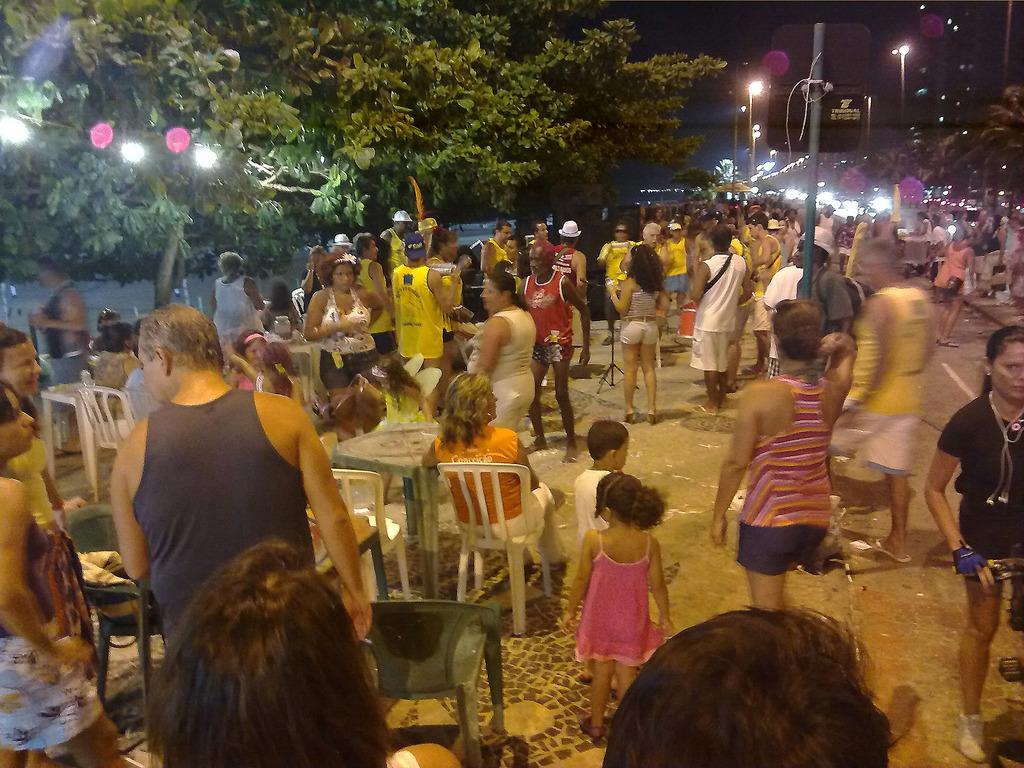In one or two sentences, can you explain what this image depicts? This image is taken during the night time. In this image we can see the light poles, lights, trees and also many people. We can see some people standing and a few are sitting on the chairs. Image also consists of the tables. We can also see the road. 